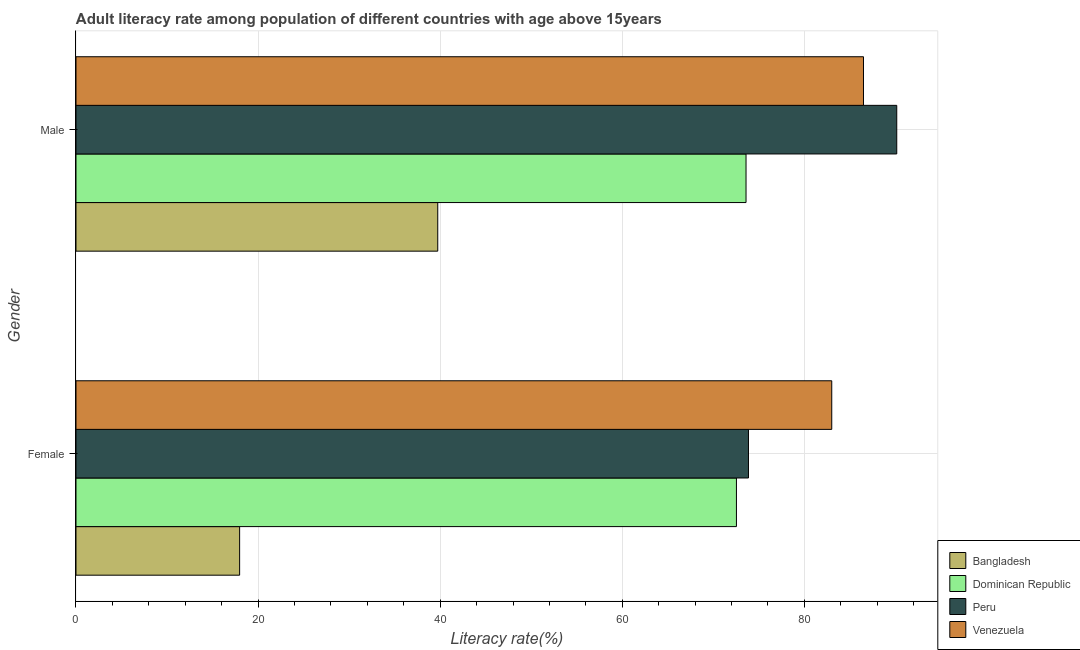How many different coloured bars are there?
Your answer should be compact. 4. How many groups of bars are there?
Keep it short and to the point. 2. How many bars are there on the 1st tick from the bottom?
Make the answer very short. 4. What is the male adult literacy rate in Dominican Republic?
Offer a very short reply. 73.59. Across all countries, what is the maximum male adult literacy rate?
Ensure brevity in your answer.  90.14. Across all countries, what is the minimum female adult literacy rate?
Ensure brevity in your answer.  17.97. In which country was the female adult literacy rate maximum?
Your answer should be compact. Venezuela. What is the total female adult literacy rate in the graph?
Offer a very short reply. 247.37. What is the difference between the male adult literacy rate in Peru and that in Bangladesh?
Offer a terse response. 50.41. What is the difference between the male adult literacy rate in Dominican Republic and the female adult literacy rate in Venezuela?
Provide a short and direct response. -9.41. What is the average female adult literacy rate per country?
Offer a terse response. 61.84. What is the difference between the male adult literacy rate and female adult literacy rate in Dominican Republic?
Your answer should be compact. 1.05. In how many countries, is the male adult literacy rate greater than 4 %?
Provide a short and direct response. 4. What is the ratio of the male adult literacy rate in Dominican Republic to that in Venezuela?
Give a very brief answer. 0.85. What does the 1st bar from the top in Female represents?
Make the answer very short. Venezuela. What does the 2nd bar from the bottom in Female represents?
Offer a very short reply. Dominican Republic. What is the difference between two consecutive major ticks on the X-axis?
Give a very brief answer. 20. How many legend labels are there?
Provide a short and direct response. 4. How are the legend labels stacked?
Offer a terse response. Vertical. What is the title of the graph?
Make the answer very short. Adult literacy rate among population of different countries with age above 15years. What is the label or title of the X-axis?
Your answer should be very brief. Literacy rate(%). What is the Literacy rate(%) in Bangladesh in Female?
Ensure brevity in your answer.  17.97. What is the Literacy rate(%) in Dominican Republic in Female?
Provide a succinct answer. 72.54. What is the Literacy rate(%) of Peru in Female?
Ensure brevity in your answer.  73.86. What is the Literacy rate(%) of Venezuela in Female?
Your response must be concise. 83. What is the Literacy rate(%) in Bangladesh in Male?
Keep it short and to the point. 39.73. What is the Literacy rate(%) in Dominican Republic in Male?
Make the answer very short. 73.59. What is the Literacy rate(%) of Peru in Male?
Provide a short and direct response. 90.14. What is the Literacy rate(%) of Venezuela in Male?
Offer a terse response. 86.49. Across all Gender, what is the maximum Literacy rate(%) of Bangladesh?
Provide a short and direct response. 39.73. Across all Gender, what is the maximum Literacy rate(%) in Dominican Republic?
Your answer should be very brief. 73.59. Across all Gender, what is the maximum Literacy rate(%) of Peru?
Your response must be concise. 90.14. Across all Gender, what is the maximum Literacy rate(%) of Venezuela?
Ensure brevity in your answer.  86.49. Across all Gender, what is the minimum Literacy rate(%) of Bangladesh?
Give a very brief answer. 17.97. Across all Gender, what is the minimum Literacy rate(%) of Dominican Republic?
Offer a very short reply. 72.54. Across all Gender, what is the minimum Literacy rate(%) in Peru?
Provide a succinct answer. 73.86. Across all Gender, what is the minimum Literacy rate(%) of Venezuela?
Ensure brevity in your answer.  83. What is the total Literacy rate(%) of Bangladesh in the graph?
Provide a short and direct response. 57.7. What is the total Literacy rate(%) of Dominican Republic in the graph?
Offer a very short reply. 146.13. What is the total Literacy rate(%) in Peru in the graph?
Offer a very short reply. 164. What is the total Literacy rate(%) of Venezuela in the graph?
Your response must be concise. 169.49. What is the difference between the Literacy rate(%) in Bangladesh in Female and that in Male?
Your response must be concise. -21.76. What is the difference between the Literacy rate(%) of Dominican Republic in Female and that in Male?
Your answer should be compact. -1.05. What is the difference between the Literacy rate(%) in Peru in Female and that in Male?
Offer a terse response. -16.29. What is the difference between the Literacy rate(%) in Venezuela in Female and that in Male?
Ensure brevity in your answer.  -3.48. What is the difference between the Literacy rate(%) in Bangladesh in Female and the Literacy rate(%) in Dominican Republic in Male?
Offer a very short reply. -55.62. What is the difference between the Literacy rate(%) of Bangladesh in Female and the Literacy rate(%) of Peru in Male?
Your answer should be very brief. -72.17. What is the difference between the Literacy rate(%) in Bangladesh in Female and the Literacy rate(%) in Venezuela in Male?
Your answer should be very brief. -68.52. What is the difference between the Literacy rate(%) of Dominican Republic in Female and the Literacy rate(%) of Peru in Male?
Give a very brief answer. -17.61. What is the difference between the Literacy rate(%) in Dominican Republic in Female and the Literacy rate(%) in Venezuela in Male?
Offer a very short reply. -13.95. What is the difference between the Literacy rate(%) in Peru in Female and the Literacy rate(%) in Venezuela in Male?
Provide a short and direct response. -12.63. What is the average Literacy rate(%) of Bangladesh per Gender?
Provide a succinct answer. 28.85. What is the average Literacy rate(%) of Dominican Republic per Gender?
Your answer should be compact. 73.06. What is the average Literacy rate(%) of Peru per Gender?
Ensure brevity in your answer.  82. What is the average Literacy rate(%) in Venezuela per Gender?
Your answer should be compact. 84.75. What is the difference between the Literacy rate(%) of Bangladesh and Literacy rate(%) of Dominican Republic in Female?
Ensure brevity in your answer.  -54.56. What is the difference between the Literacy rate(%) in Bangladesh and Literacy rate(%) in Peru in Female?
Your answer should be very brief. -55.89. What is the difference between the Literacy rate(%) in Bangladesh and Literacy rate(%) in Venezuela in Female?
Keep it short and to the point. -65.03. What is the difference between the Literacy rate(%) in Dominican Republic and Literacy rate(%) in Peru in Female?
Make the answer very short. -1.32. What is the difference between the Literacy rate(%) in Dominican Republic and Literacy rate(%) in Venezuela in Female?
Your answer should be compact. -10.47. What is the difference between the Literacy rate(%) in Peru and Literacy rate(%) in Venezuela in Female?
Your answer should be compact. -9.15. What is the difference between the Literacy rate(%) of Bangladesh and Literacy rate(%) of Dominican Republic in Male?
Keep it short and to the point. -33.86. What is the difference between the Literacy rate(%) of Bangladesh and Literacy rate(%) of Peru in Male?
Your answer should be very brief. -50.41. What is the difference between the Literacy rate(%) in Bangladesh and Literacy rate(%) in Venezuela in Male?
Offer a terse response. -46.76. What is the difference between the Literacy rate(%) in Dominican Republic and Literacy rate(%) in Peru in Male?
Ensure brevity in your answer.  -16.55. What is the difference between the Literacy rate(%) of Dominican Republic and Literacy rate(%) of Venezuela in Male?
Provide a short and direct response. -12.9. What is the difference between the Literacy rate(%) in Peru and Literacy rate(%) in Venezuela in Male?
Ensure brevity in your answer.  3.65. What is the ratio of the Literacy rate(%) in Bangladesh in Female to that in Male?
Make the answer very short. 0.45. What is the ratio of the Literacy rate(%) of Dominican Republic in Female to that in Male?
Give a very brief answer. 0.99. What is the ratio of the Literacy rate(%) in Peru in Female to that in Male?
Ensure brevity in your answer.  0.82. What is the ratio of the Literacy rate(%) of Venezuela in Female to that in Male?
Make the answer very short. 0.96. What is the difference between the highest and the second highest Literacy rate(%) in Bangladesh?
Keep it short and to the point. 21.76. What is the difference between the highest and the second highest Literacy rate(%) in Dominican Republic?
Make the answer very short. 1.05. What is the difference between the highest and the second highest Literacy rate(%) of Peru?
Give a very brief answer. 16.29. What is the difference between the highest and the second highest Literacy rate(%) in Venezuela?
Your answer should be very brief. 3.48. What is the difference between the highest and the lowest Literacy rate(%) of Bangladesh?
Ensure brevity in your answer.  21.76. What is the difference between the highest and the lowest Literacy rate(%) in Dominican Republic?
Your response must be concise. 1.05. What is the difference between the highest and the lowest Literacy rate(%) in Peru?
Keep it short and to the point. 16.29. What is the difference between the highest and the lowest Literacy rate(%) of Venezuela?
Offer a terse response. 3.48. 